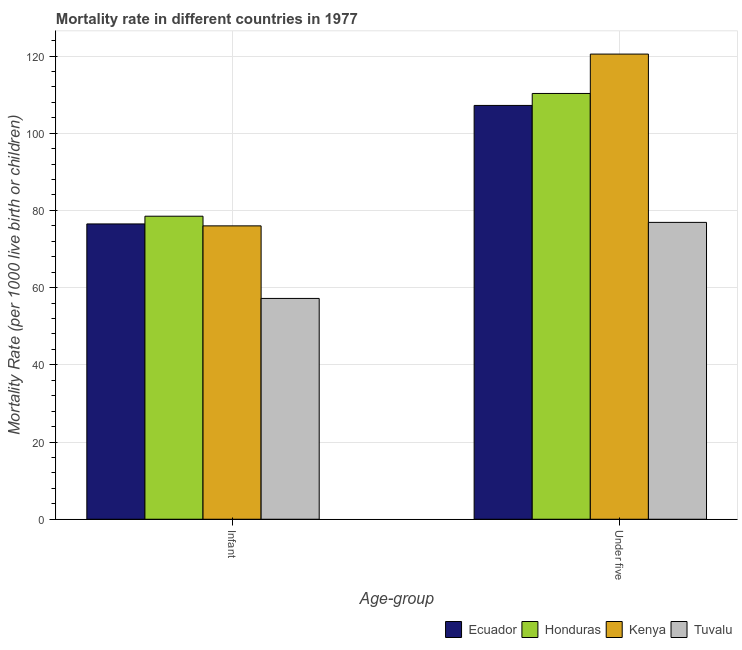How many different coloured bars are there?
Ensure brevity in your answer.  4. How many groups of bars are there?
Make the answer very short. 2. Are the number of bars per tick equal to the number of legend labels?
Keep it short and to the point. Yes. How many bars are there on the 2nd tick from the left?
Offer a very short reply. 4. How many bars are there on the 1st tick from the right?
Give a very brief answer. 4. What is the label of the 2nd group of bars from the left?
Provide a succinct answer. Under five. What is the under-5 mortality rate in Honduras?
Provide a succinct answer. 110.3. Across all countries, what is the maximum infant mortality rate?
Your response must be concise. 78.5. Across all countries, what is the minimum infant mortality rate?
Give a very brief answer. 57.2. In which country was the under-5 mortality rate maximum?
Your answer should be compact. Kenya. In which country was the infant mortality rate minimum?
Provide a short and direct response. Tuvalu. What is the total under-5 mortality rate in the graph?
Provide a short and direct response. 414.9. What is the difference between the infant mortality rate in Tuvalu and that in Kenya?
Your answer should be very brief. -18.8. What is the difference between the infant mortality rate in Honduras and the under-5 mortality rate in Tuvalu?
Your answer should be compact. 1.6. What is the average infant mortality rate per country?
Make the answer very short. 72.05. What is the difference between the under-5 mortality rate and infant mortality rate in Tuvalu?
Your answer should be very brief. 19.7. In how many countries, is the infant mortality rate greater than 4 ?
Provide a succinct answer. 4. What is the ratio of the infant mortality rate in Kenya to that in Tuvalu?
Make the answer very short. 1.33. What does the 2nd bar from the left in Under five represents?
Make the answer very short. Honduras. What does the 3rd bar from the right in Infant represents?
Your response must be concise. Honduras. How many countries are there in the graph?
Offer a very short reply. 4. What is the difference between two consecutive major ticks on the Y-axis?
Provide a succinct answer. 20. Are the values on the major ticks of Y-axis written in scientific E-notation?
Your answer should be very brief. No. Does the graph contain grids?
Ensure brevity in your answer.  Yes. How are the legend labels stacked?
Give a very brief answer. Horizontal. What is the title of the graph?
Give a very brief answer. Mortality rate in different countries in 1977. What is the label or title of the X-axis?
Ensure brevity in your answer.  Age-group. What is the label or title of the Y-axis?
Ensure brevity in your answer.  Mortality Rate (per 1000 live birth or children). What is the Mortality Rate (per 1000 live birth or children) of Ecuador in Infant?
Ensure brevity in your answer.  76.5. What is the Mortality Rate (per 1000 live birth or children) in Honduras in Infant?
Your answer should be very brief. 78.5. What is the Mortality Rate (per 1000 live birth or children) of Kenya in Infant?
Offer a very short reply. 76. What is the Mortality Rate (per 1000 live birth or children) of Tuvalu in Infant?
Make the answer very short. 57.2. What is the Mortality Rate (per 1000 live birth or children) in Ecuador in Under five?
Provide a succinct answer. 107.2. What is the Mortality Rate (per 1000 live birth or children) in Honduras in Under five?
Your answer should be compact. 110.3. What is the Mortality Rate (per 1000 live birth or children) of Kenya in Under five?
Ensure brevity in your answer.  120.5. What is the Mortality Rate (per 1000 live birth or children) in Tuvalu in Under five?
Your answer should be very brief. 76.9. Across all Age-group, what is the maximum Mortality Rate (per 1000 live birth or children) in Ecuador?
Provide a short and direct response. 107.2. Across all Age-group, what is the maximum Mortality Rate (per 1000 live birth or children) of Honduras?
Provide a short and direct response. 110.3. Across all Age-group, what is the maximum Mortality Rate (per 1000 live birth or children) of Kenya?
Ensure brevity in your answer.  120.5. Across all Age-group, what is the maximum Mortality Rate (per 1000 live birth or children) in Tuvalu?
Keep it short and to the point. 76.9. Across all Age-group, what is the minimum Mortality Rate (per 1000 live birth or children) in Ecuador?
Ensure brevity in your answer.  76.5. Across all Age-group, what is the minimum Mortality Rate (per 1000 live birth or children) in Honduras?
Make the answer very short. 78.5. Across all Age-group, what is the minimum Mortality Rate (per 1000 live birth or children) of Kenya?
Offer a very short reply. 76. Across all Age-group, what is the minimum Mortality Rate (per 1000 live birth or children) in Tuvalu?
Provide a succinct answer. 57.2. What is the total Mortality Rate (per 1000 live birth or children) of Ecuador in the graph?
Ensure brevity in your answer.  183.7. What is the total Mortality Rate (per 1000 live birth or children) in Honduras in the graph?
Your answer should be compact. 188.8. What is the total Mortality Rate (per 1000 live birth or children) in Kenya in the graph?
Provide a succinct answer. 196.5. What is the total Mortality Rate (per 1000 live birth or children) in Tuvalu in the graph?
Offer a terse response. 134.1. What is the difference between the Mortality Rate (per 1000 live birth or children) of Ecuador in Infant and that in Under five?
Your answer should be very brief. -30.7. What is the difference between the Mortality Rate (per 1000 live birth or children) of Honduras in Infant and that in Under five?
Keep it short and to the point. -31.8. What is the difference between the Mortality Rate (per 1000 live birth or children) of Kenya in Infant and that in Under five?
Ensure brevity in your answer.  -44.5. What is the difference between the Mortality Rate (per 1000 live birth or children) in Tuvalu in Infant and that in Under five?
Give a very brief answer. -19.7. What is the difference between the Mortality Rate (per 1000 live birth or children) of Ecuador in Infant and the Mortality Rate (per 1000 live birth or children) of Honduras in Under five?
Keep it short and to the point. -33.8. What is the difference between the Mortality Rate (per 1000 live birth or children) in Ecuador in Infant and the Mortality Rate (per 1000 live birth or children) in Kenya in Under five?
Your answer should be compact. -44. What is the difference between the Mortality Rate (per 1000 live birth or children) in Honduras in Infant and the Mortality Rate (per 1000 live birth or children) in Kenya in Under five?
Offer a very short reply. -42. What is the difference between the Mortality Rate (per 1000 live birth or children) in Kenya in Infant and the Mortality Rate (per 1000 live birth or children) in Tuvalu in Under five?
Offer a terse response. -0.9. What is the average Mortality Rate (per 1000 live birth or children) in Ecuador per Age-group?
Offer a terse response. 91.85. What is the average Mortality Rate (per 1000 live birth or children) in Honduras per Age-group?
Ensure brevity in your answer.  94.4. What is the average Mortality Rate (per 1000 live birth or children) of Kenya per Age-group?
Keep it short and to the point. 98.25. What is the average Mortality Rate (per 1000 live birth or children) of Tuvalu per Age-group?
Make the answer very short. 67.05. What is the difference between the Mortality Rate (per 1000 live birth or children) of Ecuador and Mortality Rate (per 1000 live birth or children) of Honduras in Infant?
Your answer should be very brief. -2. What is the difference between the Mortality Rate (per 1000 live birth or children) in Ecuador and Mortality Rate (per 1000 live birth or children) in Kenya in Infant?
Provide a short and direct response. 0.5. What is the difference between the Mortality Rate (per 1000 live birth or children) of Ecuador and Mortality Rate (per 1000 live birth or children) of Tuvalu in Infant?
Your answer should be compact. 19.3. What is the difference between the Mortality Rate (per 1000 live birth or children) of Honduras and Mortality Rate (per 1000 live birth or children) of Tuvalu in Infant?
Your answer should be very brief. 21.3. What is the difference between the Mortality Rate (per 1000 live birth or children) in Ecuador and Mortality Rate (per 1000 live birth or children) in Honduras in Under five?
Your answer should be compact. -3.1. What is the difference between the Mortality Rate (per 1000 live birth or children) in Ecuador and Mortality Rate (per 1000 live birth or children) in Kenya in Under five?
Offer a very short reply. -13.3. What is the difference between the Mortality Rate (per 1000 live birth or children) of Ecuador and Mortality Rate (per 1000 live birth or children) of Tuvalu in Under five?
Offer a terse response. 30.3. What is the difference between the Mortality Rate (per 1000 live birth or children) of Honduras and Mortality Rate (per 1000 live birth or children) of Kenya in Under five?
Ensure brevity in your answer.  -10.2. What is the difference between the Mortality Rate (per 1000 live birth or children) in Honduras and Mortality Rate (per 1000 live birth or children) in Tuvalu in Under five?
Provide a short and direct response. 33.4. What is the difference between the Mortality Rate (per 1000 live birth or children) in Kenya and Mortality Rate (per 1000 live birth or children) in Tuvalu in Under five?
Your response must be concise. 43.6. What is the ratio of the Mortality Rate (per 1000 live birth or children) in Ecuador in Infant to that in Under five?
Your response must be concise. 0.71. What is the ratio of the Mortality Rate (per 1000 live birth or children) in Honduras in Infant to that in Under five?
Provide a succinct answer. 0.71. What is the ratio of the Mortality Rate (per 1000 live birth or children) in Kenya in Infant to that in Under five?
Make the answer very short. 0.63. What is the ratio of the Mortality Rate (per 1000 live birth or children) in Tuvalu in Infant to that in Under five?
Your answer should be very brief. 0.74. What is the difference between the highest and the second highest Mortality Rate (per 1000 live birth or children) of Ecuador?
Keep it short and to the point. 30.7. What is the difference between the highest and the second highest Mortality Rate (per 1000 live birth or children) in Honduras?
Provide a short and direct response. 31.8. What is the difference between the highest and the second highest Mortality Rate (per 1000 live birth or children) of Kenya?
Give a very brief answer. 44.5. What is the difference between the highest and the second highest Mortality Rate (per 1000 live birth or children) in Tuvalu?
Your answer should be compact. 19.7. What is the difference between the highest and the lowest Mortality Rate (per 1000 live birth or children) in Ecuador?
Make the answer very short. 30.7. What is the difference between the highest and the lowest Mortality Rate (per 1000 live birth or children) in Honduras?
Your answer should be very brief. 31.8. What is the difference between the highest and the lowest Mortality Rate (per 1000 live birth or children) of Kenya?
Your response must be concise. 44.5. What is the difference between the highest and the lowest Mortality Rate (per 1000 live birth or children) in Tuvalu?
Your response must be concise. 19.7. 